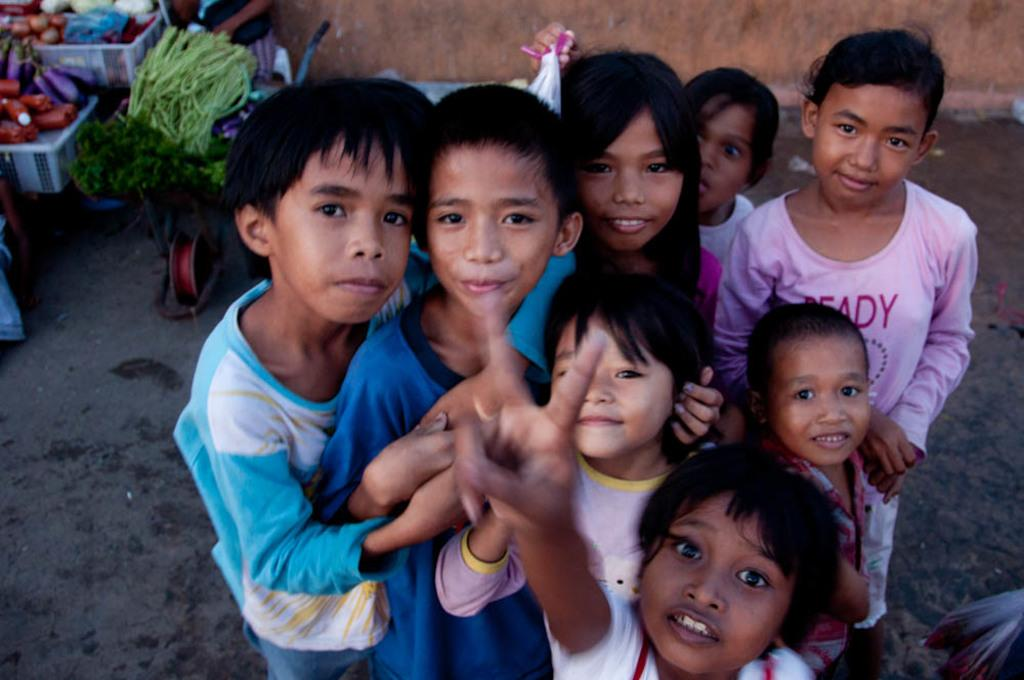What is the main subject of the image? There is a group of people standing in the image. What else can be seen in the image besides the people? There are vegetables in a basket in the image. What type of background is visible in the image? There is a wall and ground visible in the image. How many apples are on the feet of the people in the image? There are no apples present on the feet of the people in the image. What type of club can be seen in the hands of the people in the image? There is no club visible in the hands of the people in the image. 